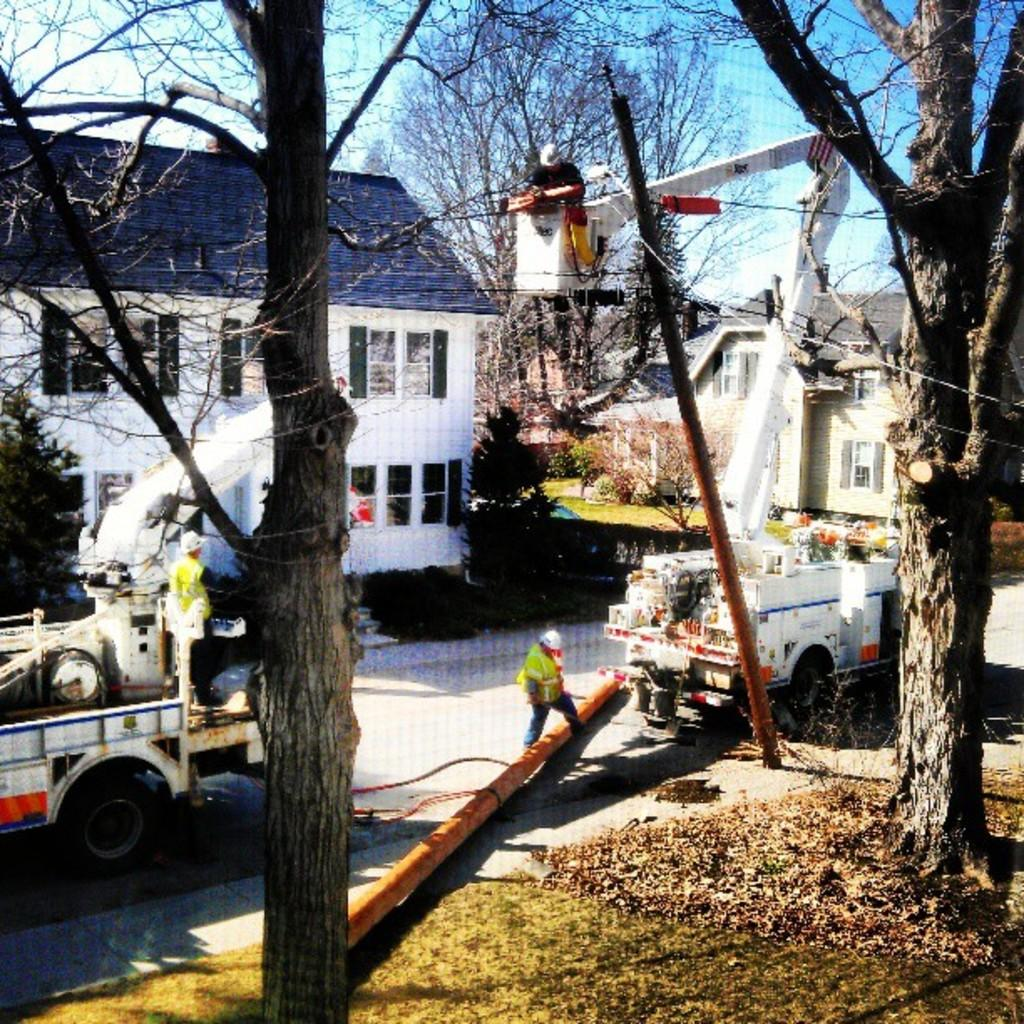What can be seen on the road in the image? There are vehicles on the road in the image. What structures are present in the image? A: There are poles and houses in the image. What type of vegetation is visible in the image? There are trees in the image. How many people can be seen in the image? There are two persons in the image. What is visible in the background of the image? The sky is visible in the background of the image. What type of oatmeal is being used to power the vehicles in the image? There is no oatmeal present in the image, and vehicles are not powered by oatmeal. Can you explain the magic system used by the trees in the image? There is no magic system present in the image, and trees do not possess magical abilities. 